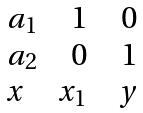Convert formula to latex. <formula><loc_0><loc_0><loc_500><loc_500>\begin{matrix} a _ { 1 } \quad 1 \quad 0 \\ a _ { 2 } \quad 0 \quad 1 \\ x \quad x _ { 1 } \quad y \end{matrix}</formula> 